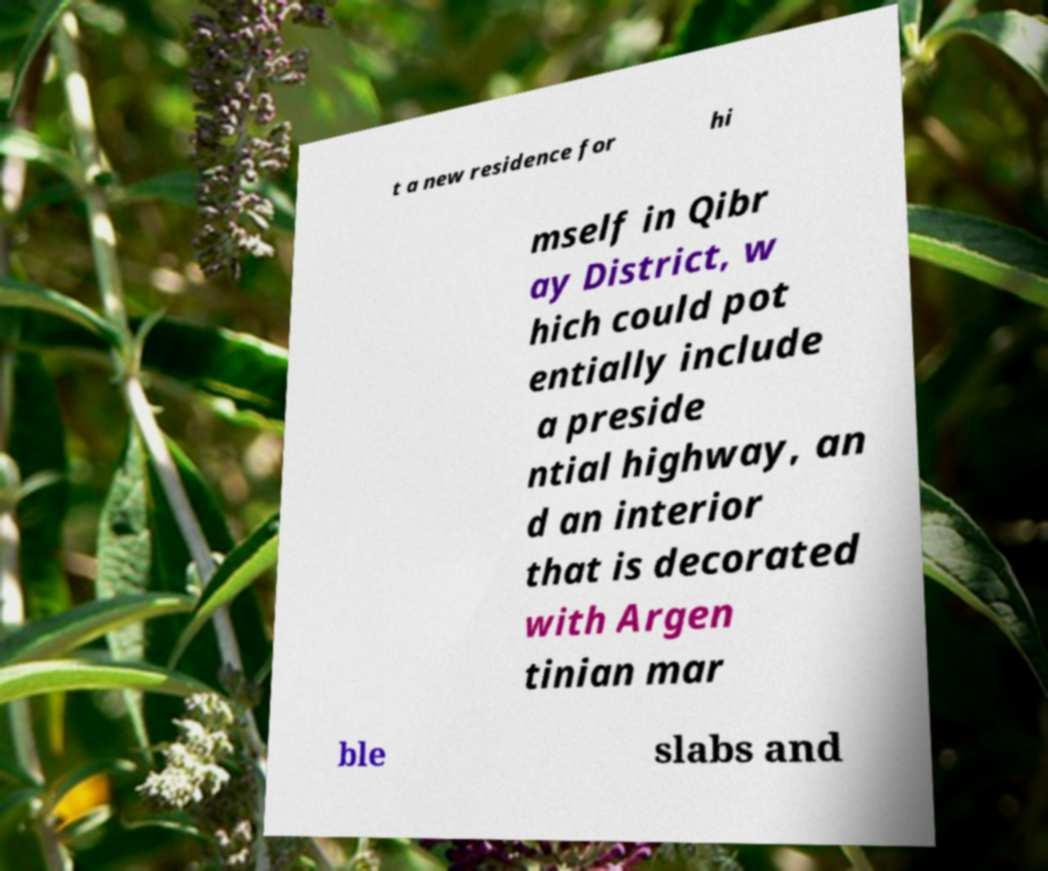Could you extract and type out the text from this image? t a new residence for hi mself in Qibr ay District, w hich could pot entially include a preside ntial highway, an d an interior that is decorated with Argen tinian mar ble slabs and 